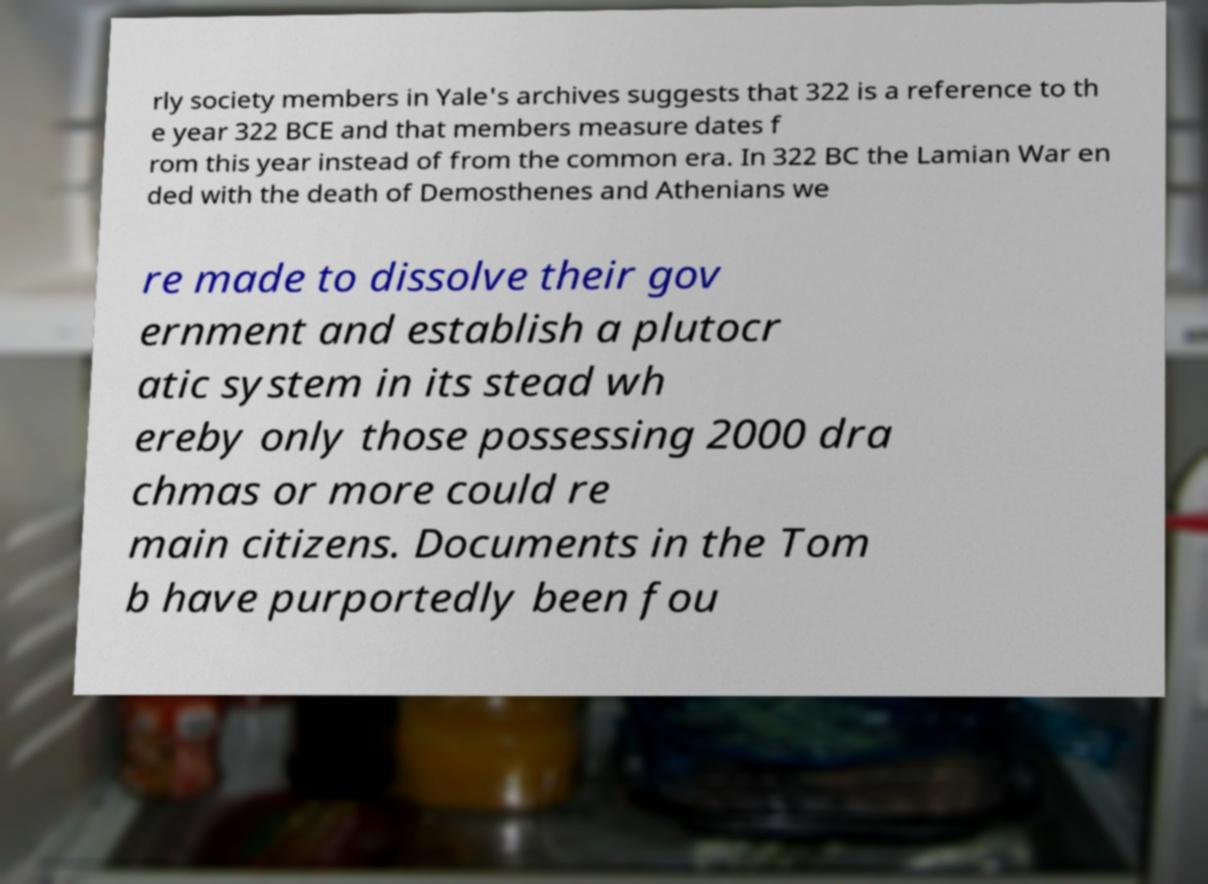What messages or text are displayed in this image? I need them in a readable, typed format. rly society members in Yale's archives suggests that 322 is a reference to th e year 322 BCE and that members measure dates f rom this year instead of from the common era. In 322 BC the Lamian War en ded with the death of Demosthenes and Athenians we re made to dissolve their gov ernment and establish a plutocr atic system in its stead wh ereby only those possessing 2000 dra chmas or more could re main citizens. Documents in the Tom b have purportedly been fou 